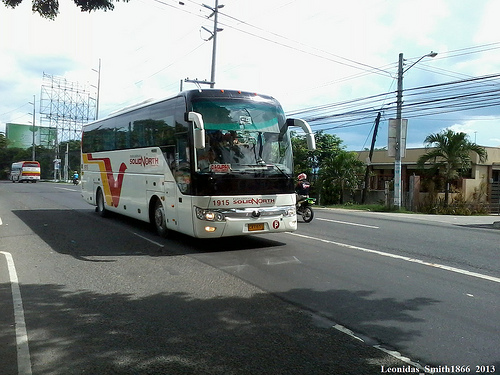Please provide a short description for this region: [0.57, 0.44, 0.65, 0.57]. A motorcycle parked adjacent to a bus on the road. 